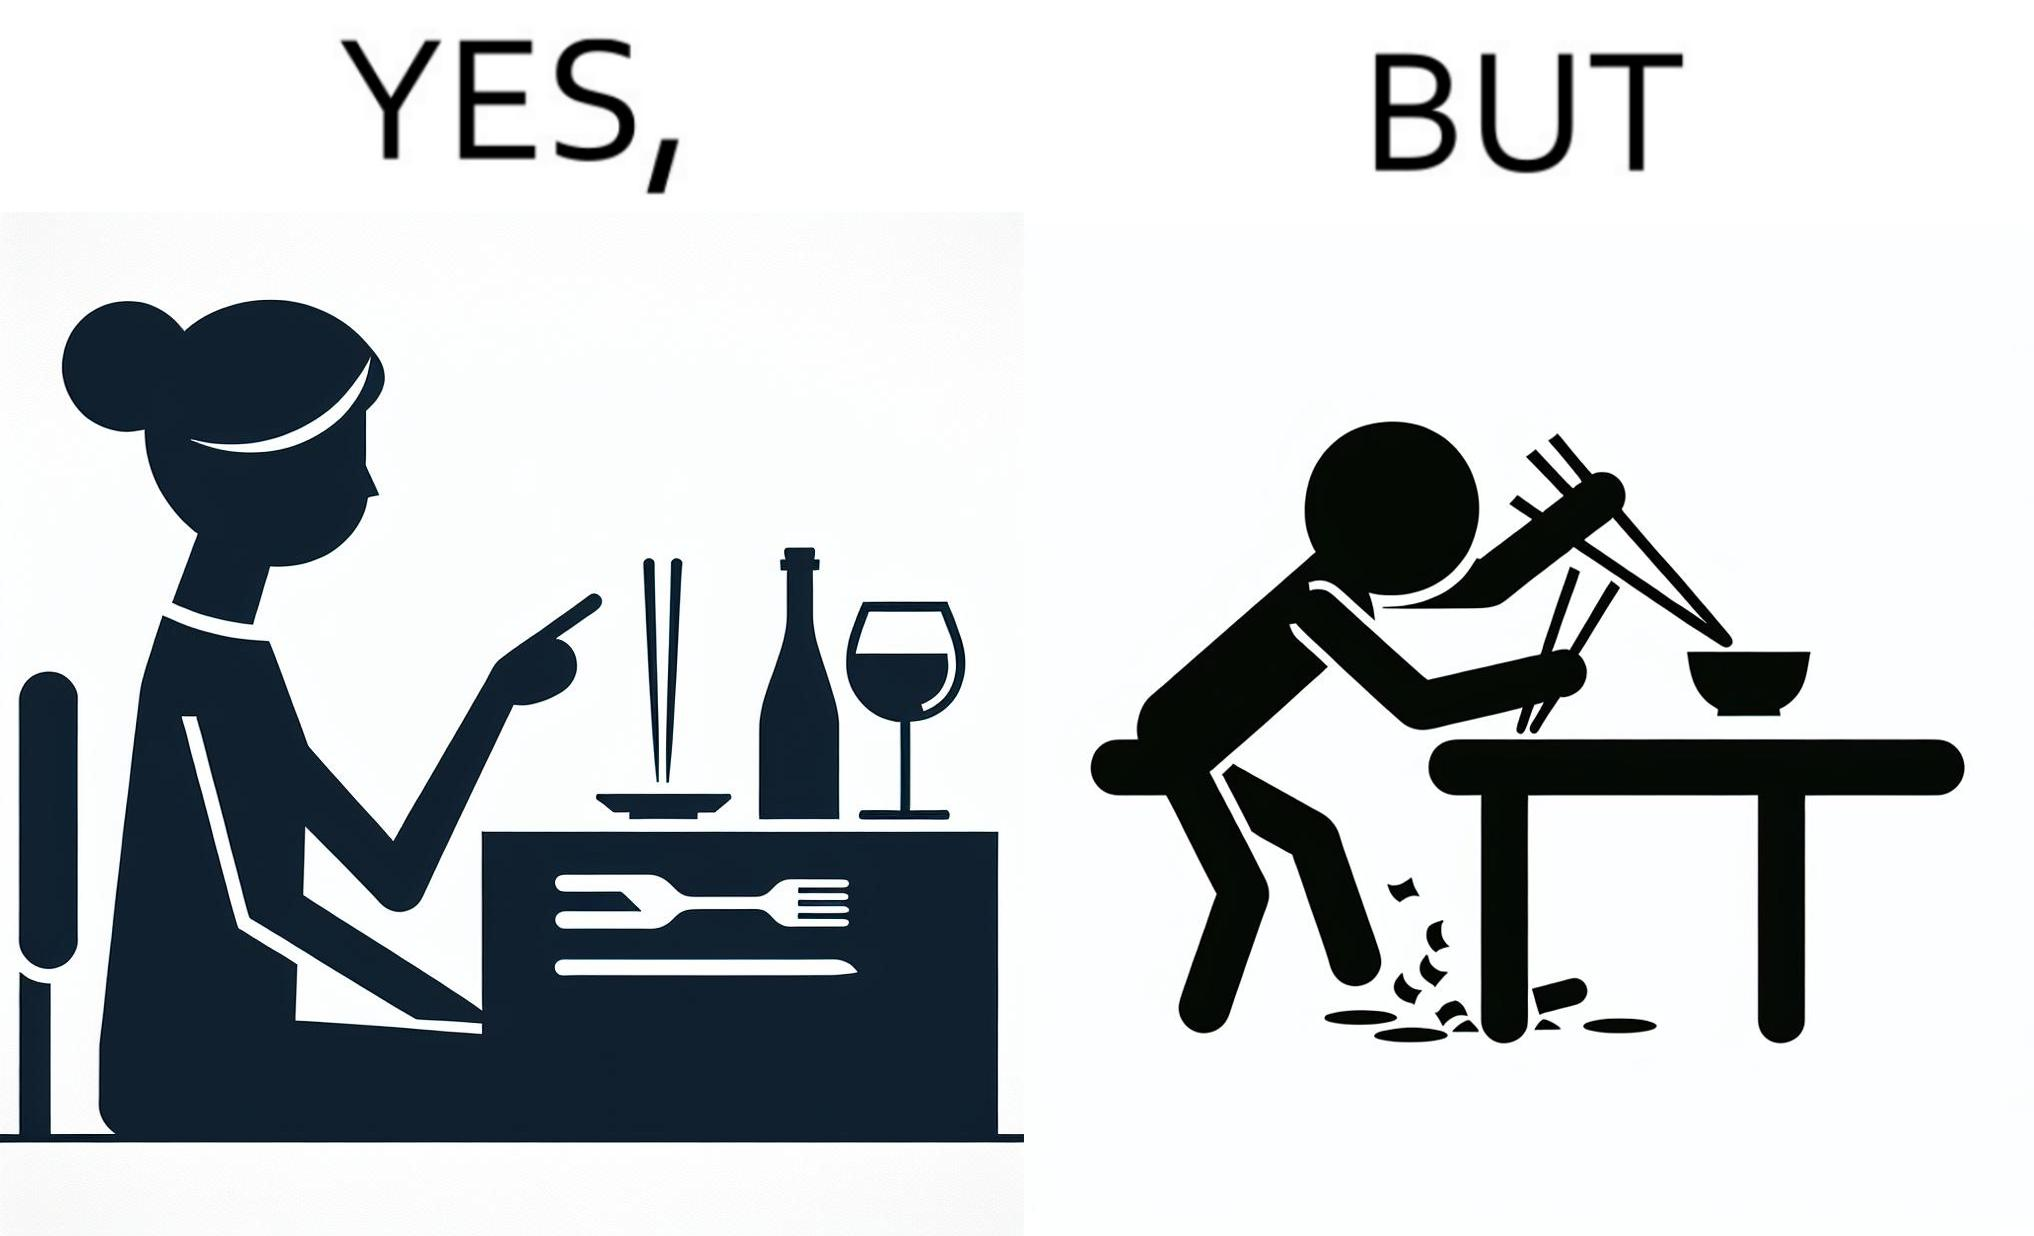Describe the contrast between the left and right parts of this image. In the left part of the image: The image shows a woman sitting at a table in a restaruant pointing to chopsticks on her table. There is also a wine glass, a fork and a knief on her table. In the right part of the image: The image shows a person using chopstick to pick up food from the cup. The person is not able to handle food with chopstick well and is dropping the food around the cup on the table. 